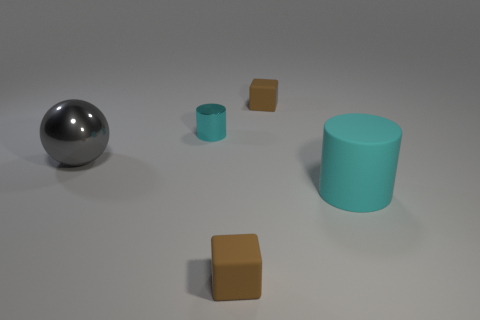What is the shape of the small brown matte thing behind the ball?
Make the answer very short. Cube. Are there any matte cubes in front of the cyan metal thing?
Give a very brief answer. Yes. There is a sphere that is made of the same material as the small cyan thing; what color is it?
Make the answer very short. Gray. Is the color of the tiny rubber object in front of the big matte thing the same as the small matte thing behind the matte cylinder?
Offer a very short reply. Yes. What number of spheres are big gray things or small rubber things?
Ensure brevity in your answer.  1. Is the number of small cylinders in front of the big gray metal thing the same as the number of small brown matte cylinders?
Offer a terse response. Yes. The big thing that is on the left side of the brown object in front of the small brown block that is behind the big shiny ball is made of what material?
Your answer should be compact. Metal. There is a tiny cylinder that is the same color as the large matte thing; what material is it?
Your response must be concise. Metal. How many things are either large things on the left side of the tiny cyan object or big cyan metal cylinders?
Keep it short and to the point. 1. What number of objects are either tiny brown rubber things or blocks behind the cyan metal cylinder?
Your response must be concise. 2. 